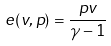Convert formula to latex. <formula><loc_0><loc_0><loc_500><loc_500>e ( v , p ) = \frac { p v } { \gamma - 1 }</formula> 